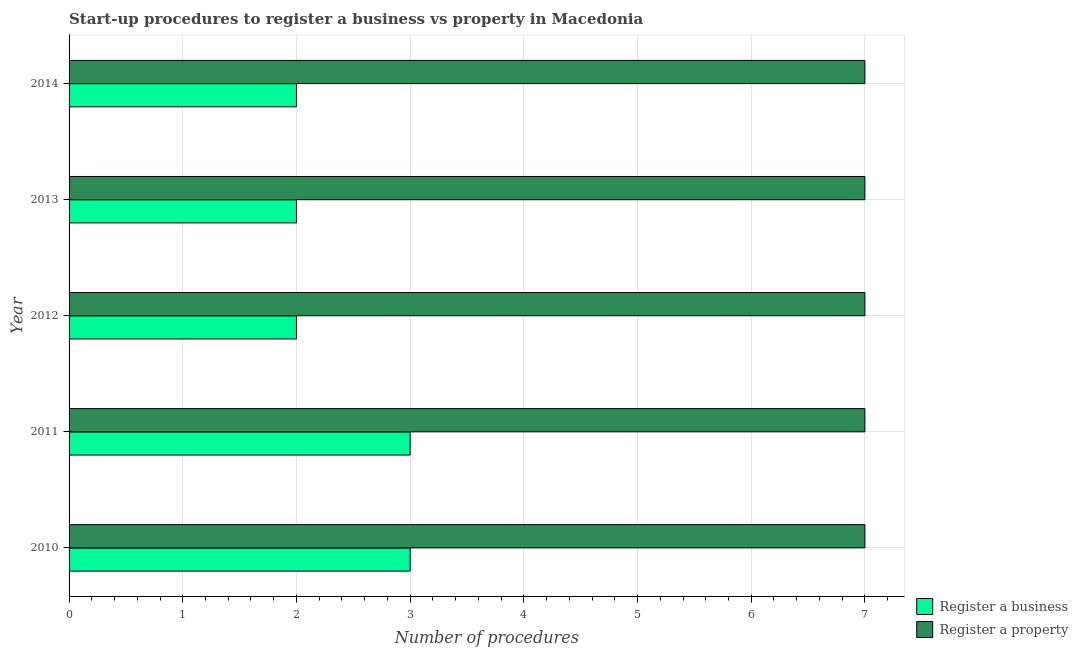How many different coloured bars are there?
Provide a succinct answer. 2. How many groups of bars are there?
Your answer should be very brief. 5. What is the label of the 1st group of bars from the top?
Keep it short and to the point. 2014. In how many cases, is the number of bars for a given year not equal to the number of legend labels?
Make the answer very short. 0. What is the number of procedures to register a business in 2013?
Give a very brief answer. 2. Across all years, what is the maximum number of procedures to register a business?
Keep it short and to the point. 3. Across all years, what is the minimum number of procedures to register a business?
Provide a short and direct response. 2. In which year was the number of procedures to register a business maximum?
Keep it short and to the point. 2010. In which year was the number of procedures to register a property minimum?
Your response must be concise. 2010. What is the total number of procedures to register a business in the graph?
Make the answer very short. 12. What is the difference between the number of procedures to register a property in 2011 and that in 2012?
Offer a terse response. 0. What is the difference between the number of procedures to register a property in 2013 and the number of procedures to register a business in 2011?
Your response must be concise. 4. In the year 2013, what is the difference between the number of procedures to register a business and number of procedures to register a property?
Your response must be concise. -5. Is the number of procedures to register a business in 2012 less than that in 2014?
Ensure brevity in your answer.  No. Is the difference between the number of procedures to register a business in 2010 and 2014 greater than the difference between the number of procedures to register a property in 2010 and 2014?
Keep it short and to the point. Yes. What is the difference between the highest and the second highest number of procedures to register a business?
Your answer should be very brief. 0. What is the difference between the highest and the lowest number of procedures to register a business?
Keep it short and to the point. 1. In how many years, is the number of procedures to register a business greater than the average number of procedures to register a business taken over all years?
Your answer should be very brief. 2. Is the sum of the number of procedures to register a property in 2011 and 2012 greater than the maximum number of procedures to register a business across all years?
Give a very brief answer. Yes. What does the 1st bar from the top in 2011 represents?
Your response must be concise. Register a property. What does the 1st bar from the bottom in 2011 represents?
Make the answer very short. Register a business. How many bars are there?
Ensure brevity in your answer.  10. What is the difference between two consecutive major ticks on the X-axis?
Offer a terse response. 1. Are the values on the major ticks of X-axis written in scientific E-notation?
Make the answer very short. No. Does the graph contain any zero values?
Offer a terse response. No. Where does the legend appear in the graph?
Offer a very short reply. Bottom right. How many legend labels are there?
Offer a terse response. 2. What is the title of the graph?
Offer a terse response. Start-up procedures to register a business vs property in Macedonia. What is the label or title of the X-axis?
Your answer should be compact. Number of procedures. What is the Number of procedures in Register a business in 2010?
Offer a terse response. 3. What is the Number of procedures of Register a business in 2011?
Offer a terse response. 3. What is the Number of procedures of Register a business in 2012?
Your answer should be compact. 2. What is the Number of procedures of Register a property in 2013?
Give a very brief answer. 7. What is the Number of procedures of Register a business in 2014?
Provide a succinct answer. 2. Across all years, what is the maximum Number of procedures of Register a business?
Your response must be concise. 3. Across all years, what is the minimum Number of procedures in Register a business?
Offer a very short reply. 2. Across all years, what is the minimum Number of procedures in Register a property?
Give a very brief answer. 7. What is the total Number of procedures in Register a property in the graph?
Offer a very short reply. 35. What is the difference between the Number of procedures in Register a business in 2010 and that in 2011?
Provide a short and direct response. 0. What is the difference between the Number of procedures of Register a property in 2010 and that in 2012?
Your answer should be very brief. 0. What is the difference between the Number of procedures of Register a business in 2010 and that in 2014?
Make the answer very short. 1. What is the difference between the Number of procedures of Register a property in 2010 and that in 2014?
Offer a very short reply. 0. What is the difference between the Number of procedures of Register a business in 2011 and that in 2012?
Your answer should be very brief. 1. What is the difference between the Number of procedures of Register a property in 2011 and that in 2012?
Keep it short and to the point. 0. What is the difference between the Number of procedures of Register a business in 2011 and that in 2013?
Ensure brevity in your answer.  1. What is the difference between the Number of procedures of Register a property in 2011 and that in 2013?
Your answer should be compact. 0. What is the difference between the Number of procedures in Register a business in 2012 and that in 2013?
Keep it short and to the point. 0. What is the difference between the Number of procedures in Register a property in 2012 and that in 2013?
Offer a very short reply. 0. What is the difference between the Number of procedures in Register a business in 2010 and the Number of procedures in Register a property in 2014?
Ensure brevity in your answer.  -4. What is the difference between the Number of procedures of Register a business in 2011 and the Number of procedures of Register a property in 2012?
Your answer should be very brief. -4. What is the difference between the Number of procedures in Register a business in 2012 and the Number of procedures in Register a property in 2013?
Your answer should be very brief. -5. What is the difference between the Number of procedures of Register a business in 2012 and the Number of procedures of Register a property in 2014?
Ensure brevity in your answer.  -5. What is the difference between the Number of procedures in Register a business in 2013 and the Number of procedures in Register a property in 2014?
Offer a terse response. -5. In the year 2011, what is the difference between the Number of procedures in Register a business and Number of procedures in Register a property?
Keep it short and to the point. -4. In the year 2013, what is the difference between the Number of procedures in Register a business and Number of procedures in Register a property?
Give a very brief answer. -5. What is the ratio of the Number of procedures of Register a business in 2010 to that in 2011?
Ensure brevity in your answer.  1. What is the ratio of the Number of procedures of Register a business in 2010 to that in 2014?
Offer a very short reply. 1.5. What is the ratio of the Number of procedures in Register a property in 2010 to that in 2014?
Keep it short and to the point. 1. What is the ratio of the Number of procedures of Register a business in 2011 to that in 2013?
Make the answer very short. 1.5. What is the ratio of the Number of procedures in Register a business in 2011 to that in 2014?
Ensure brevity in your answer.  1.5. What is the ratio of the Number of procedures of Register a property in 2012 to that in 2013?
Give a very brief answer. 1. What is the ratio of the Number of procedures in Register a property in 2012 to that in 2014?
Provide a short and direct response. 1. What is the ratio of the Number of procedures in Register a business in 2013 to that in 2014?
Offer a terse response. 1. What is the difference between the highest and the second highest Number of procedures of Register a property?
Your response must be concise. 0. 